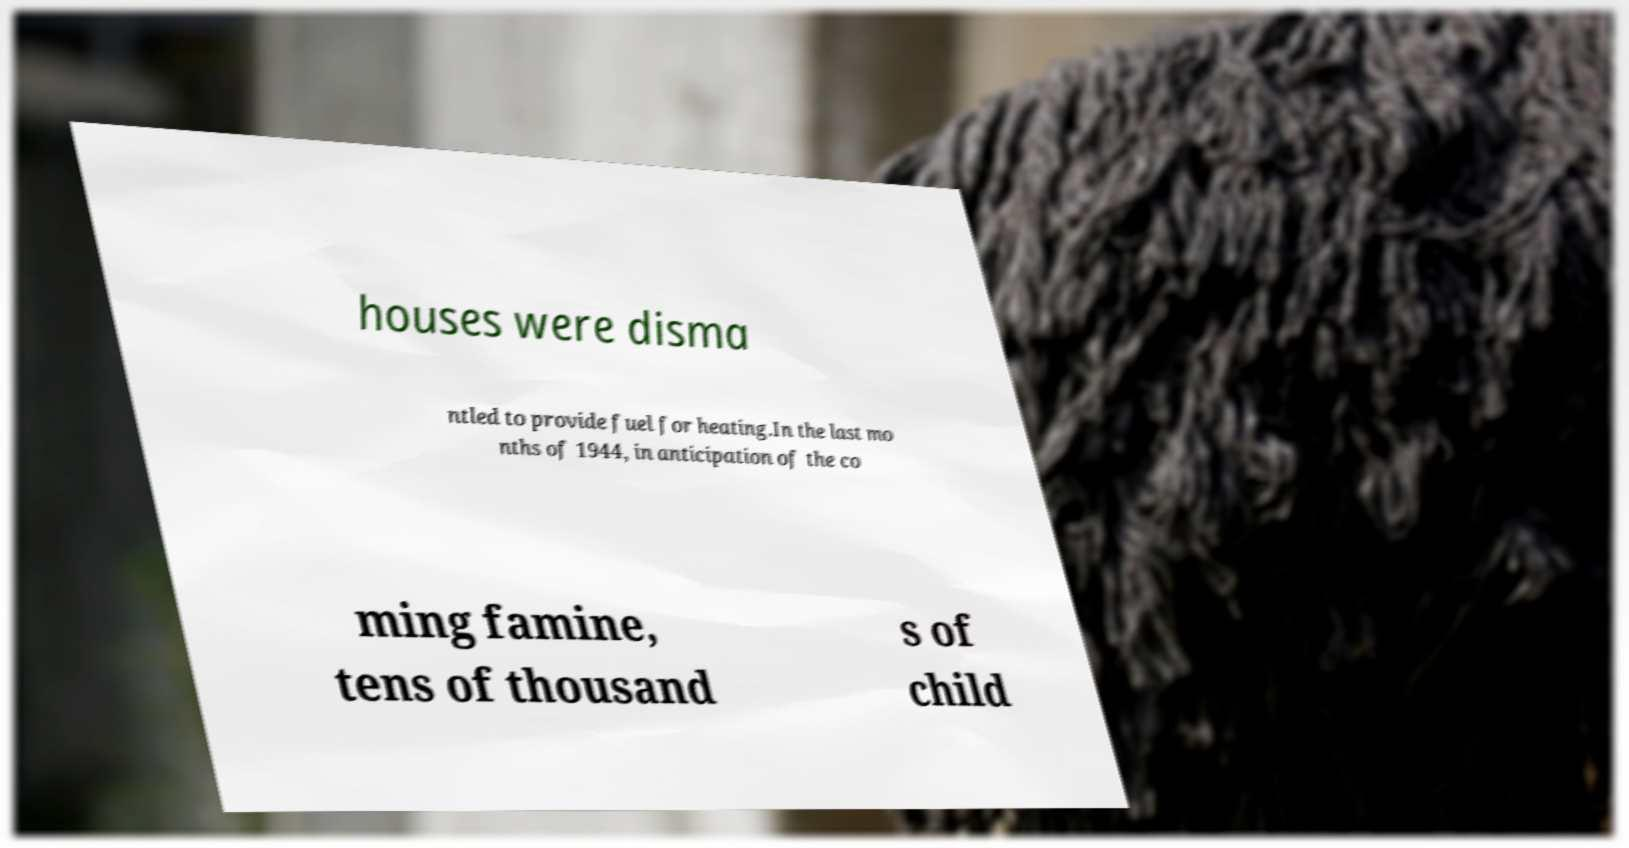There's text embedded in this image that I need extracted. Can you transcribe it verbatim? houses were disma ntled to provide fuel for heating.In the last mo nths of 1944, in anticipation of the co ming famine, tens of thousand s of child 